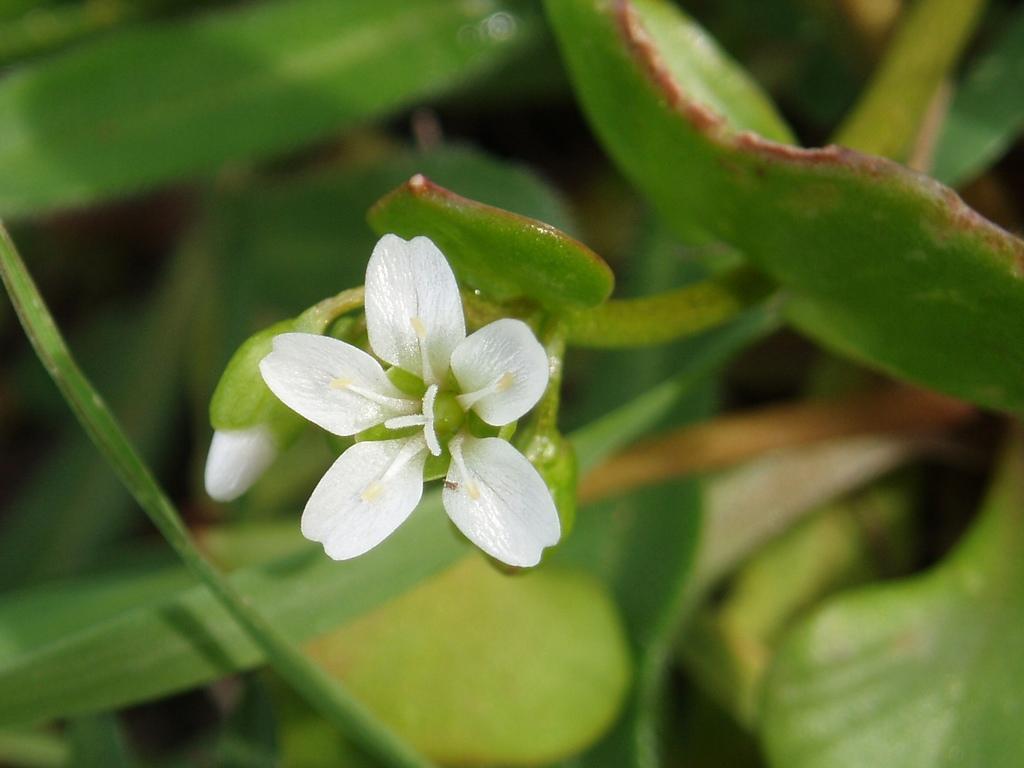Can you describe this image briefly? In this image we can see a flower and bud to the plant. 